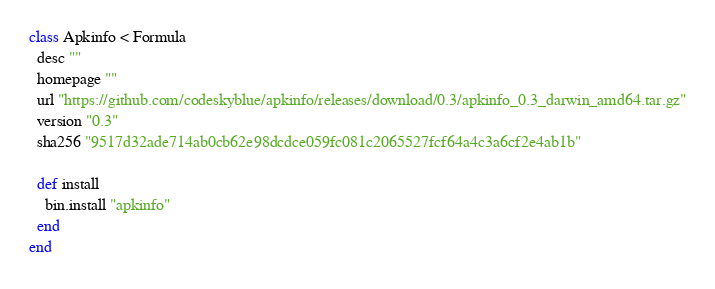<code> <loc_0><loc_0><loc_500><loc_500><_Ruby_>class Apkinfo < Formula
  desc ""
  homepage ""
  url "https://github.com/codeskyblue/apkinfo/releases/download/0.3/apkinfo_0.3_darwin_amd64.tar.gz"
  version "0.3"
  sha256 "9517d32ade714ab0cb62e98dcdce059fc081c2065527fcf64a4c3a6cf2e4ab1b"

  def install
    bin.install "apkinfo"
  end
end
</code> 